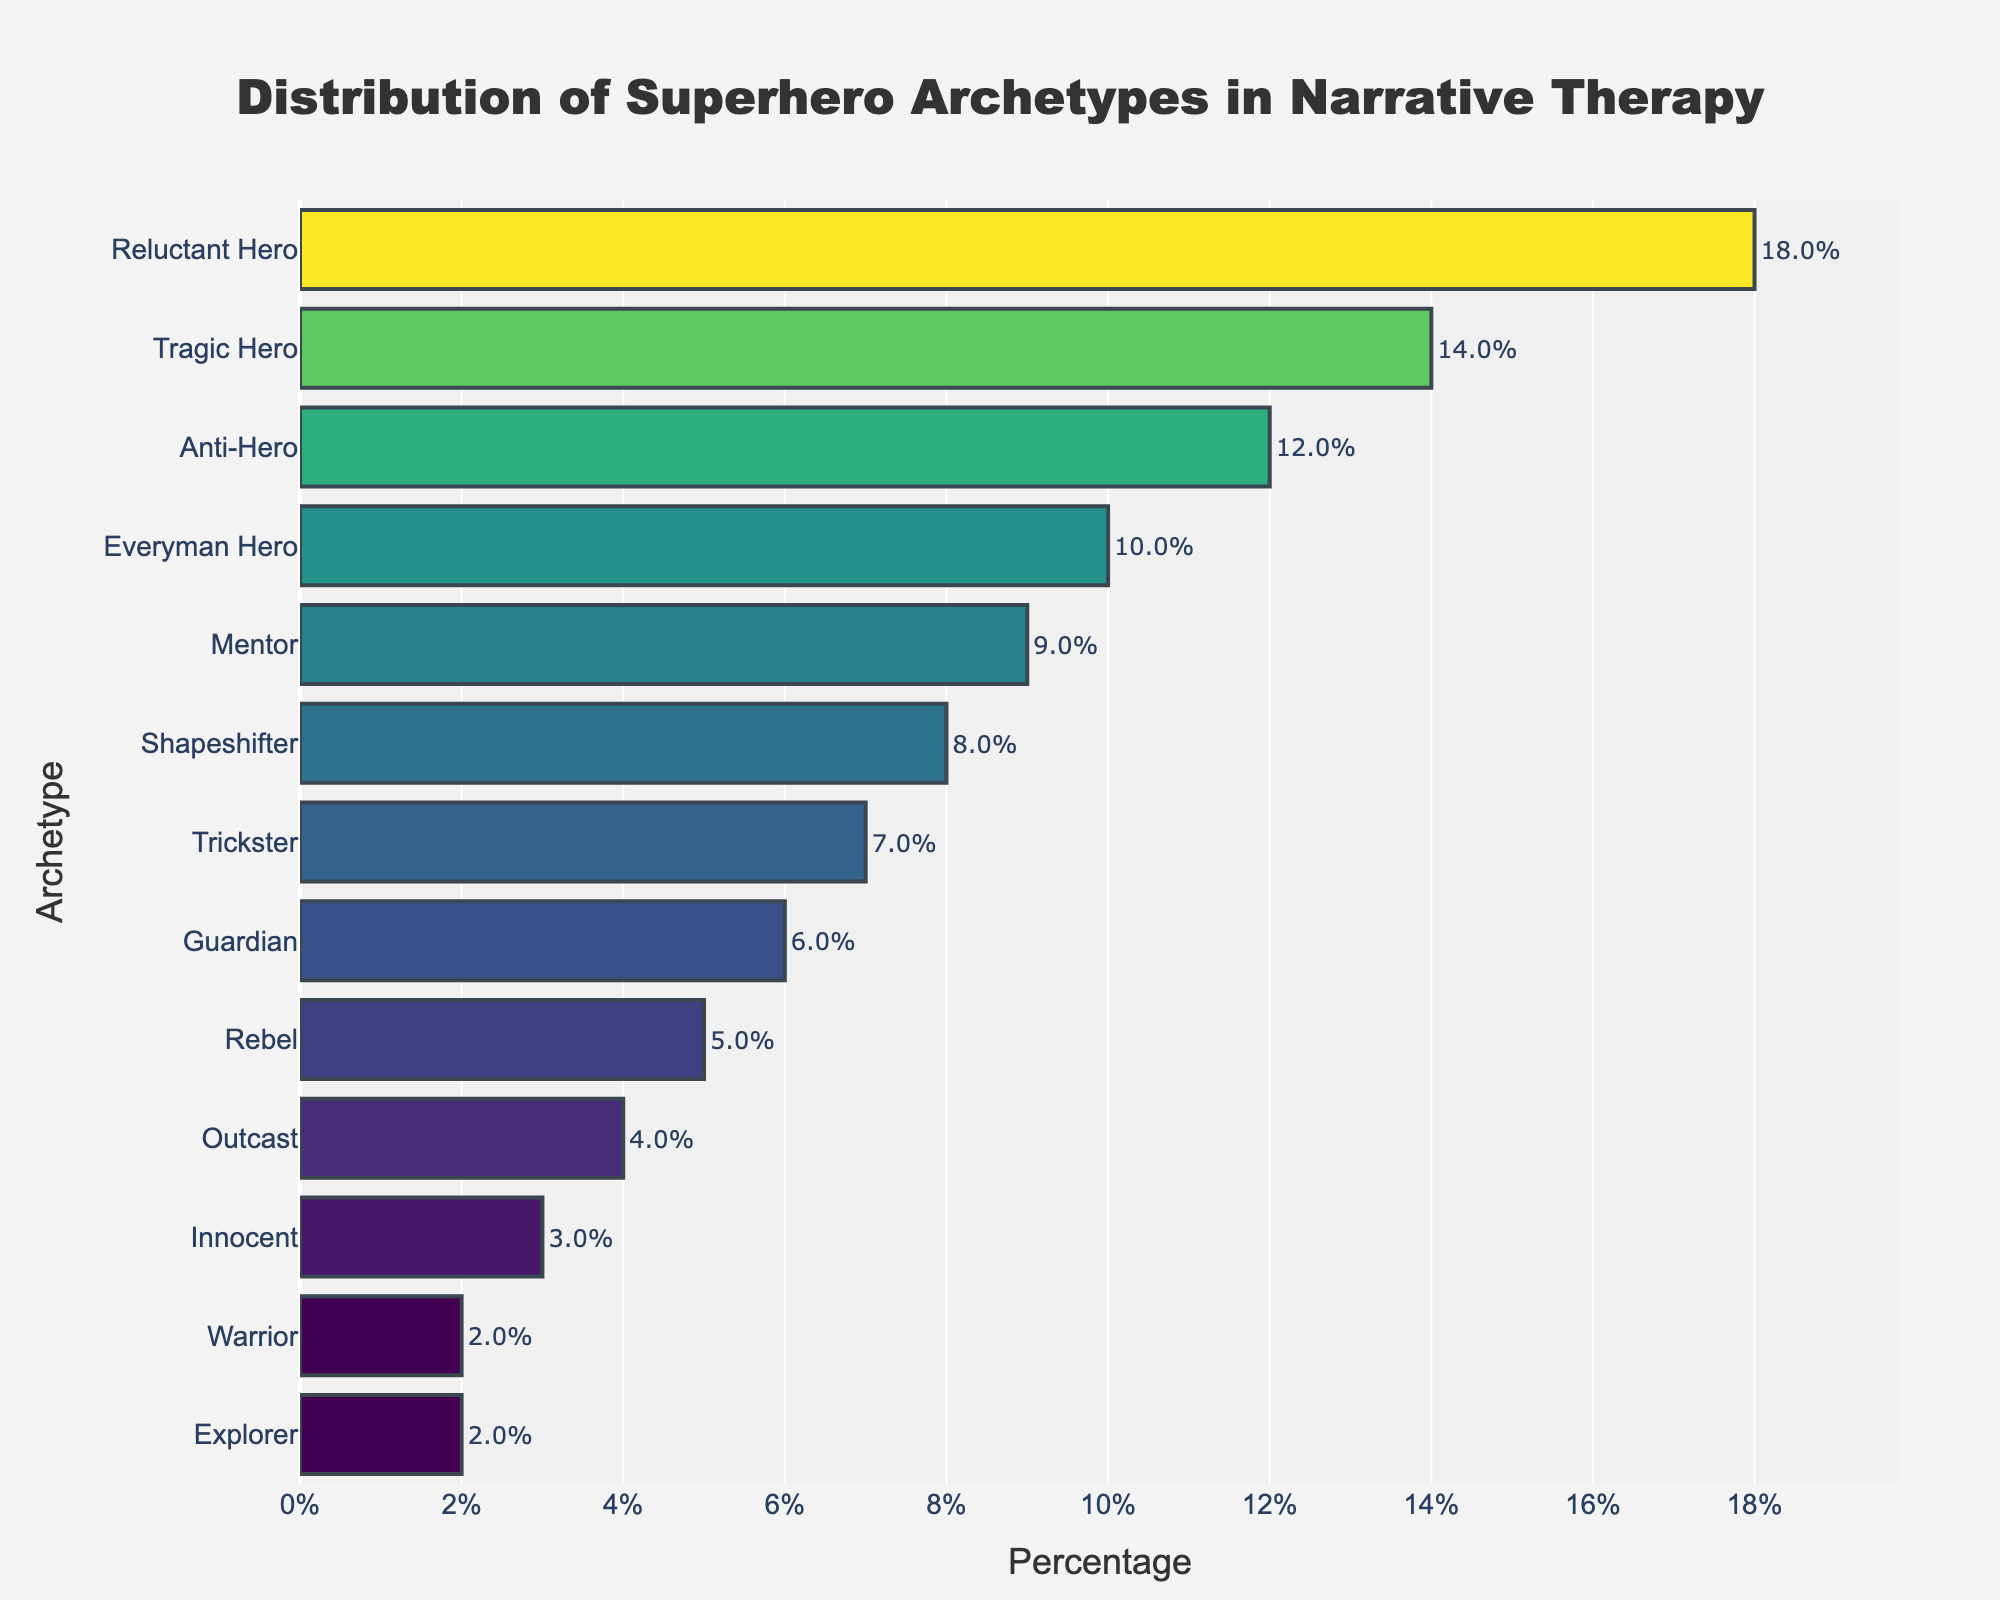what is the most common superhero archetype used in narrative therapy sessions? The bar chart shows that the "Reluctant Hero" has the highest percentage at 18%, indicating it's the most common archetype.
Answer: Reluctant Hero Which archetype is more prevalent, the Rebel or the Outcast? The bar for the "Rebel" is longer than the "Outcast," with percentages of 5% and 4%, respectively, showing that the "Rebel" is more prevalent.
Answer: Rebel What is the total percentage of the top three superhero archetypes? The top three archetypes are "Reluctant Hero" (18%), "Tragic Hero" (14%), and "Anti-Hero" (12%). Summing these percentages yields 18 + 14 + 12 = 44%.
Answer: 44% How does the percentage of the Mentor compare to the percentage of the Everyman Hero? The "Mentor" has a percentage of 9%, whereas the "Everyman Hero" has a percentage of 10%. Therefore, the "Everyman Hero" has a higher percentage.
Answer: Everyman Hero is higher What is the combined percentage of the least common archetypes (Warrior and Explorer)? Both "Warrior" and "Explorer" have percentages of 2%. Adding these together gives 2 + 2 = 4%.
Answer: 4% What is the average percentage of the archetypes above the "Trickster"? The archetypes above the "Trickster" are "Reluctant Hero" (18%), "Tragic Hero" (14%), "Anti-Hero" (12%), "Everyman Hero" (10%), "Mentor" (9%), and "Shapeshifter" (8%). The sum is 18 + 14 + 12 + 10 + 9 + 8 = 71. Dividing by 6 (the number of archetypes) gives 71/6 ≈ 11.83%.
Answer: 11.83% Which archetypes have percentages that are less than 5%? The archetypes with percentages less than 5% are "Outcast" (4%), "Innocent" (3%), "Warrior" (2%), and "Explorer" (2%), as shown by the shorter bars in the chart.
Answer: Outcast, Innocent, Warrior, Explorer What is the percentage difference between the Tragic Hero and the Shapeshifter? The "Tragic Hero" has a percentage of 14%, and the "Shapeshifter" has a percentage of 8%. The difference is 14 - 8 = 6%.
Answer: 6% What is the range of percentages covered by the archetypes? The highest percentage is for the "Reluctant Hero" at 18%, and the lowest is a tie between the "Warrior" and "Explorer" at 2%. The range is calculated as 18 - 2 = 16%.
Answer: 16% What is the median percentage of all the archetypes? To find the median, first list the percentages in ascending order: 2, 2, 3, 4, 5, 6, 7, 8, 9, 10, 12, 14, 18. With 13 values, the middle one is the 7th value. So, the median percentage is 7%.
Answer: 7% 